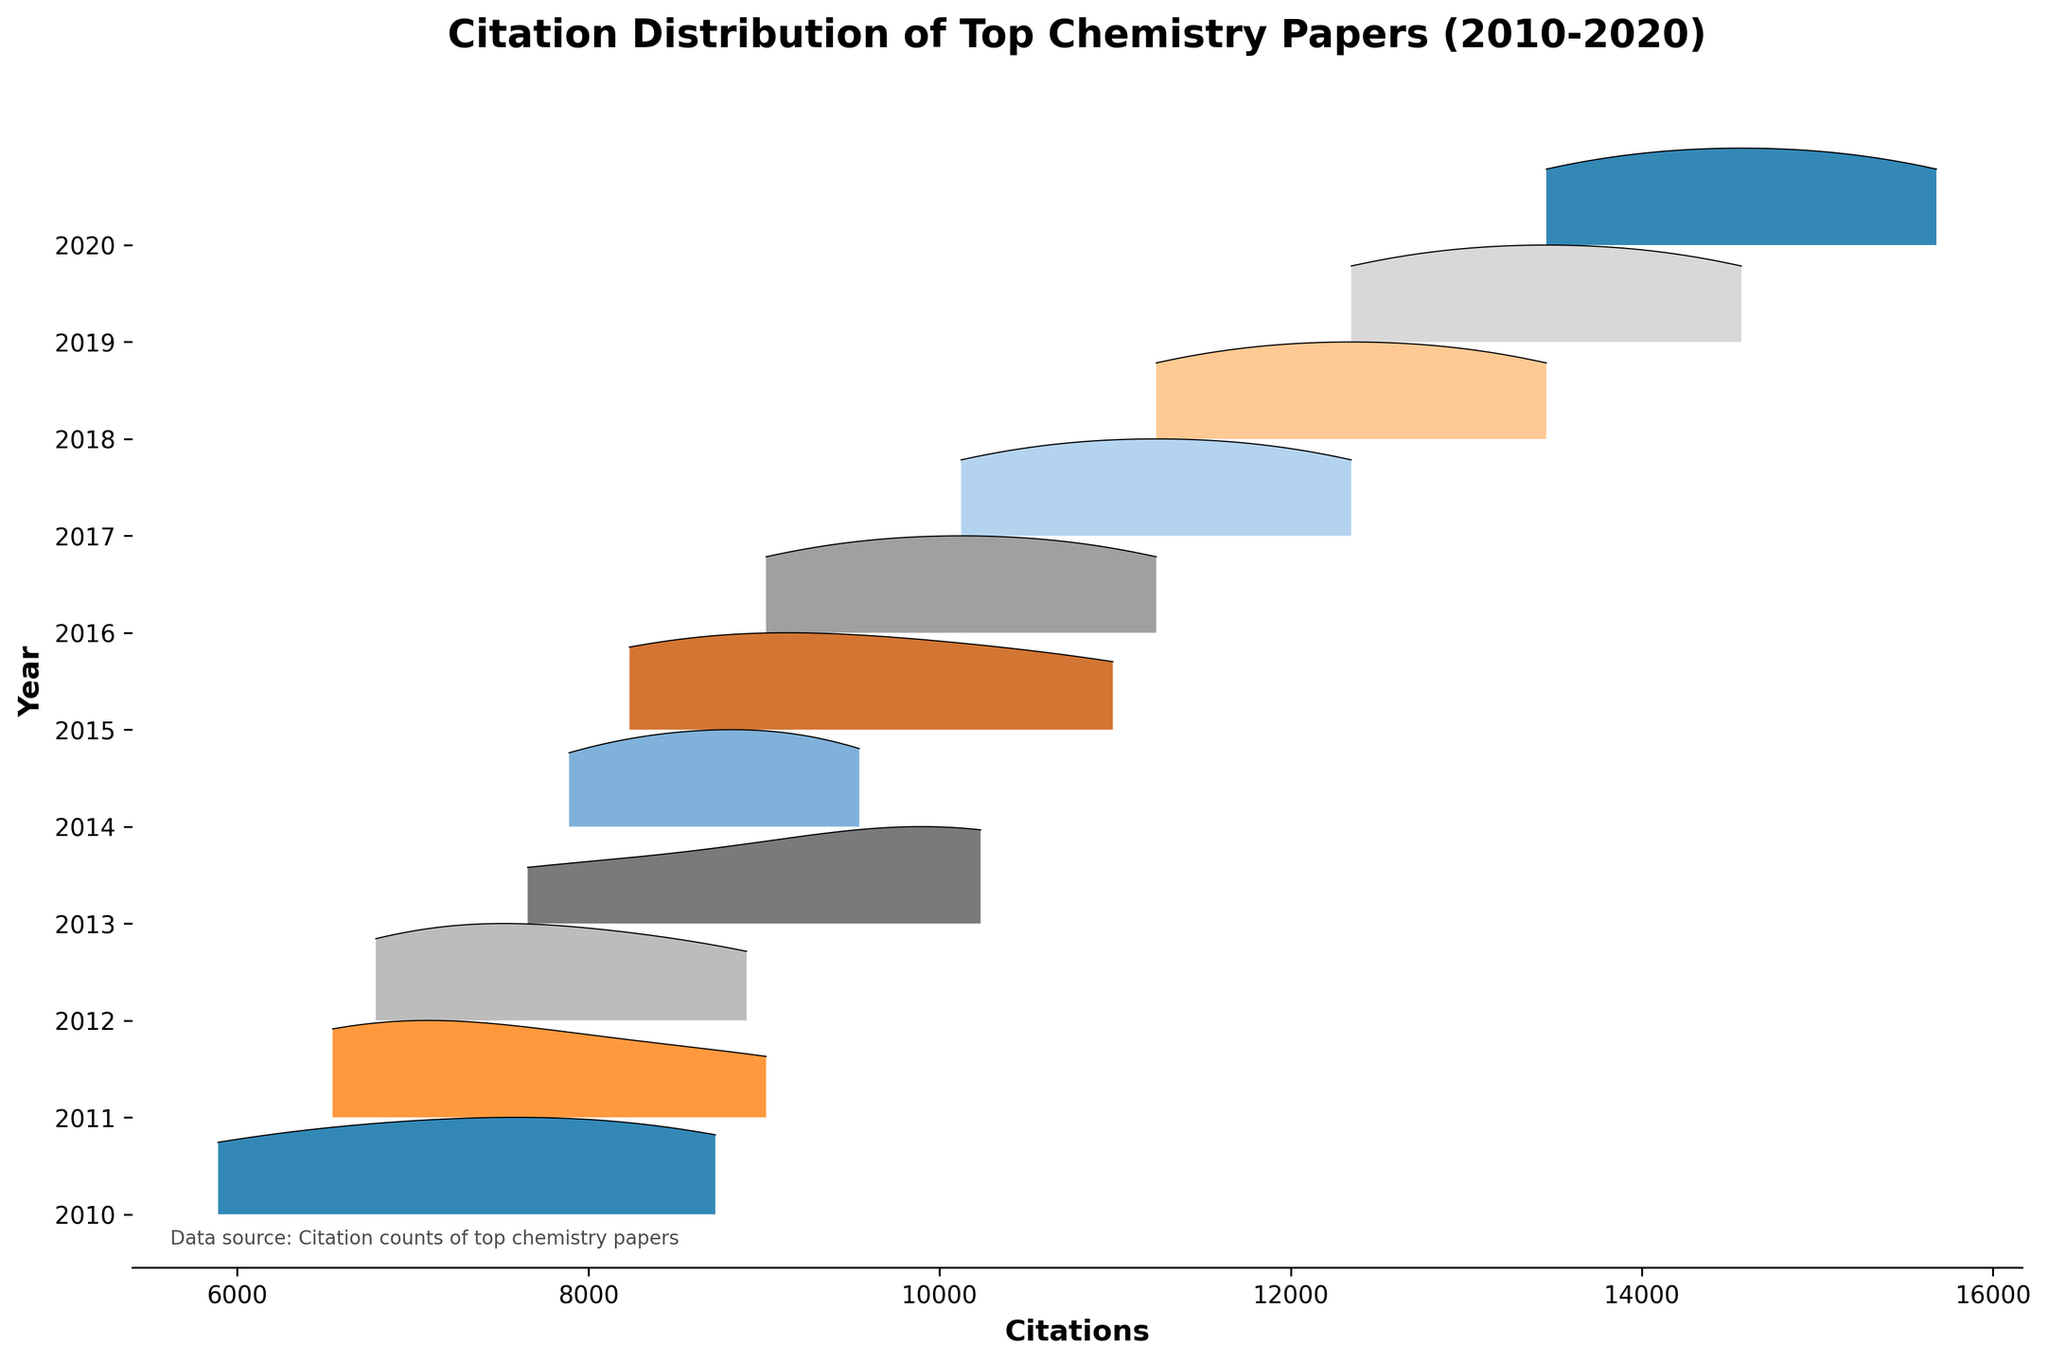What's the title of the figure? The title is displayed at the top of the figure in bold text. It should summarize the main subject of the plot.
Answer: Citation Distribution of Top Chemistry Papers (2010-2020) What does the x-axis represent? The x-axis label, found at the bottom of the plot, indicates what is being measured horizontally across the chart.
Answer: Citations Which year had the paper with the highest citation count? By scanning the peaks of each ridgeline, the highest peak overall can be identified, and the corresponding year can be noted.
Answer: 2020 How many unique years are displayed in the figure? By counting the number of different labels on the y-axis, we can determine the number of unique years represented.
Answer: 11 In which year did the range of citation counts appear to be most narrow? By comparing the spread of each ridgeline, the year with the smallest spread can be determined visually.
Answer: 2011 What is the general trend in citation counts from 2010 to 2020? Observing the overall shape and height of the ridgelines from left to right, conclusions can be drawn about how citation counts have changed over time.
Answer: Increasing Which two consecutive years have the most similar citation distributions? By visually comparing the shapes and spans of adjacent ridgelines, the most similar distributions can be identified.
Answer: 2018 and 2019 Was there any year where no paper exceeded 10,000 citations? Observing each ridgeline, checking if any of them do not extend to the 10,000 citation mark will reveal the answer.
Answer: No Which year shows the highest concentration of top-cited papers? Identify the year with the tallest and most compressed peak, indicating a higher concentration of heavily cited papers.
Answer: 2017 Which year had a notable increase in citation counts compared to the previous year? By comparing the height and span of each ridgeline year-over-year, a year with a significant increase can be identified.
Answer: 2013 